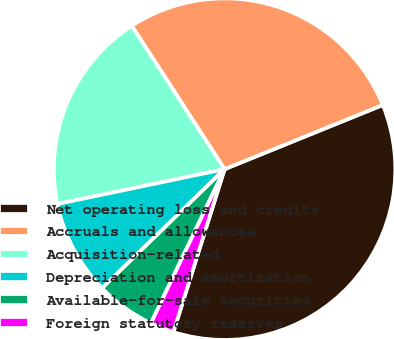Convert chart. <chart><loc_0><loc_0><loc_500><loc_500><pie_chart><fcel>Net operating loss and credits<fcel>Accruals and allowances<fcel>Acquisition-related<fcel>Depreciation and amortization<fcel>Available-for-sale securities<fcel>Foreign statutory reserves<nl><fcel>35.98%<fcel>28.01%<fcel>19.13%<fcel>9.0%<fcel>5.63%<fcel>2.25%<nl></chart> 